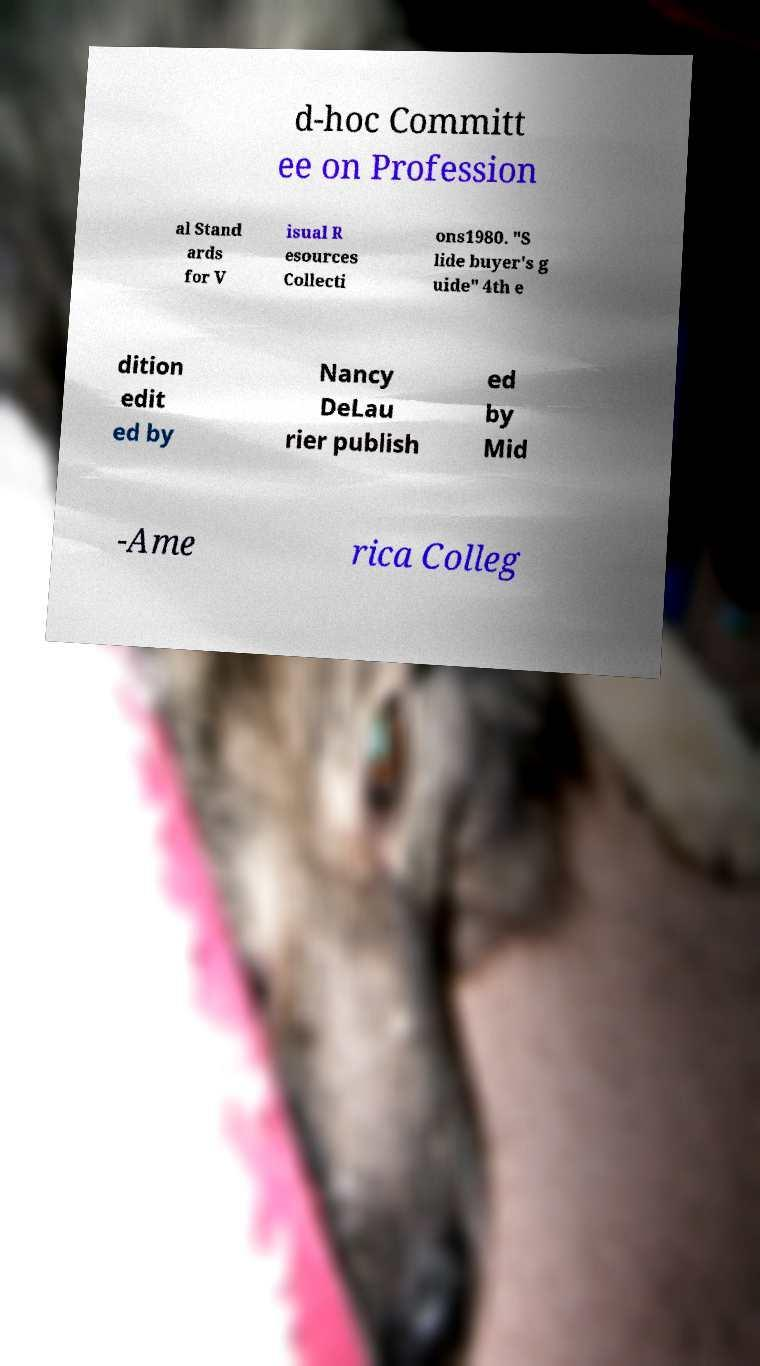Can you read and provide the text displayed in the image?This photo seems to have some interesting text. Can you extract and type it out for me? d-hoc Committ ee on Profession al Stand ards for V isual R esources Collecti ons1980. "S lide buyer's g uide" 4th e dition edit ed by Nancy DeLau rier publish ed by Mid -Ame rica Colleg 